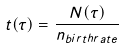Convert formula to latex. <formula><loc_0><loc_0><loc_500><loc_500>t ( \tau ) = \frac { N ( \tau ) } { n _ { b i r t h r a t e } }</formula> 